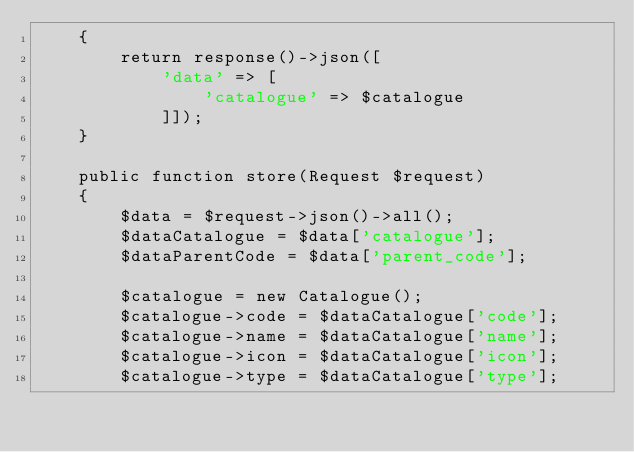<code> <loc_0><loc_0><loc_500><loc_500><_PHP_>    {
        return response()->json([
            'data' => [
                'catalogue' => $catalogue
            ]]);
    }

    public function store(Request $request)
    {
        $data = $request->json()->all();
        $dataCatalogue = $data['catalogue'];
        $dataParentCode = $data['parent_code'];

        $catalogue = new Catalogue();
        $catalogue->code = $dataCatalogue['code'];
        $catalogue->name = $dataCatalogue['name'];
        $catalogue->icon = $dataCatalogue['icon'];
        $catalogue->type = $dataCatalogue['type'];
</code> 